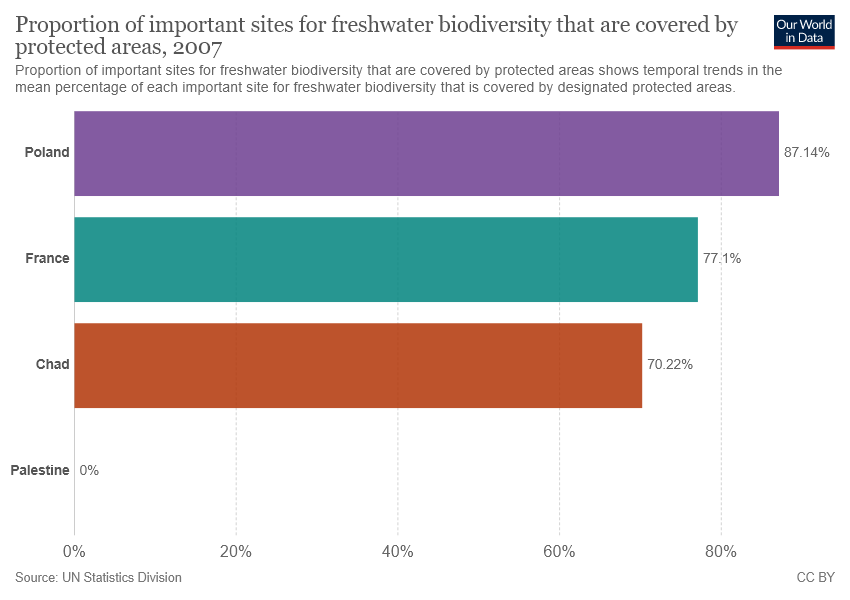Specify some key components in this picture. The difference between Poland and Chad is not greater than France. The value of Poland bar is 0.8714... 